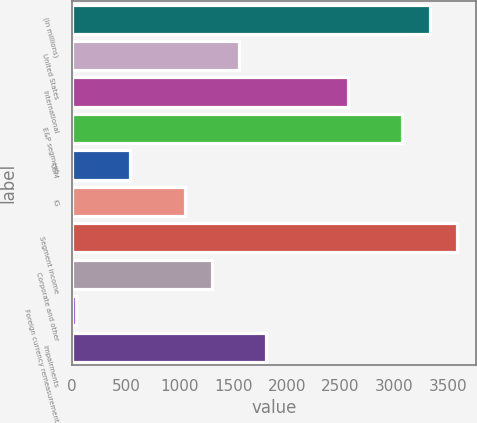Convert chart to OTSL. <chart><loc_0><loc_0><loc_500><loc_500><bar_chart><fcel>(In millions)<fcel>United States<fcel>International<fcel>E&P segment<fcel>OSM<fcel>IG<fcel>Segment income<fcel>Corporate and other<fcel>Foreign currency remeasurement<fcel>Impairments<nl><fcel>3328.8<fcel>1553.6<fcel>2568<fcel>3075.2<fcel>539.2<fcel>1046.4<fcel>3582.4<fcel>1300<fcel>32<fcel>1807.2<nl></chart> 